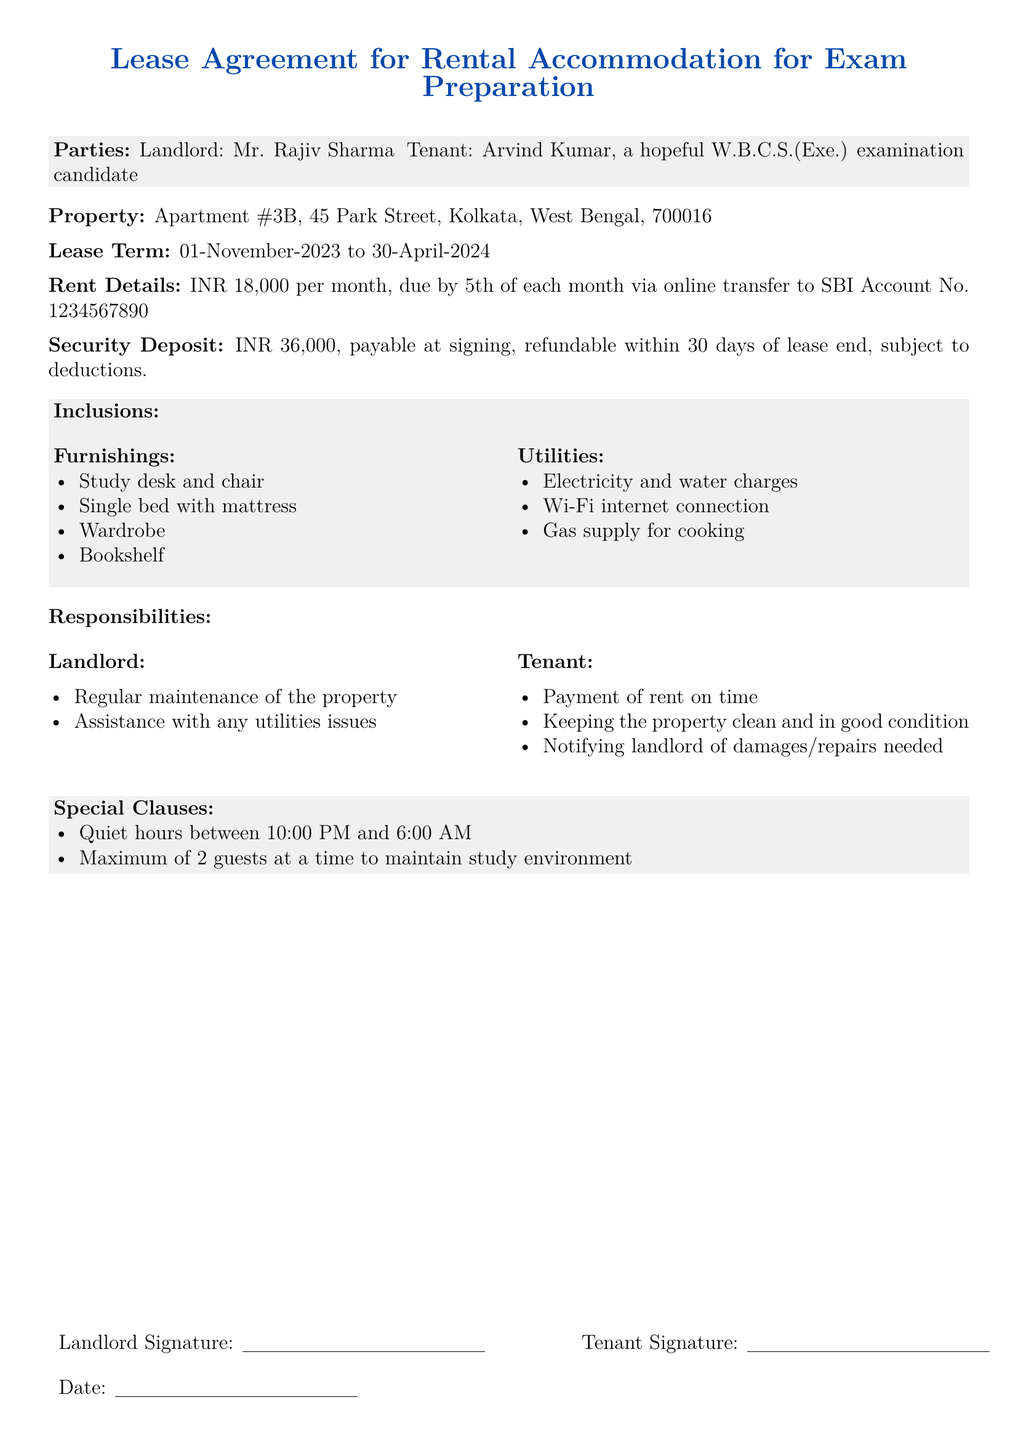What is the landlord's name? The landlord's name is indicated at the beginning of the document under "Parties."
Answer: Mr. Rajiv Sharma What is the tenant's name? The tenant's name is also indicated under "Parties."
Answer: Arvind Kumar What is the total security deposit amount? The document states the security deposit amount in the section labeled "Security Deposit."
Answer: INR 36,000 What is the lease term duration? The lease term is described at its beginning and specifies the start and end dates.
Answer: 01-November-2023 to 30-April-2024 When is the rent due each month? The document specifies when the rent payment is due in the "Rent Details" section.
Answer: 5th of each month What is included in the property furnishings? The inclusions specify furniture that is part of the lease in the "Inclusions" section.
Answer: Study desk and chair What are the landlord's responsibilities? Responsibilities of the landlord are listed in bullet points under "Responsibilities."
Answer: Regular maintenance of the property What is the maximum number of guests allowed? The document specifies this limit under "Special Clauses."
Answer: 2 guests What is the monthly rent? The "Rent Details" section reveals the amount to be paid monthly.
Answer: INR 18,000 